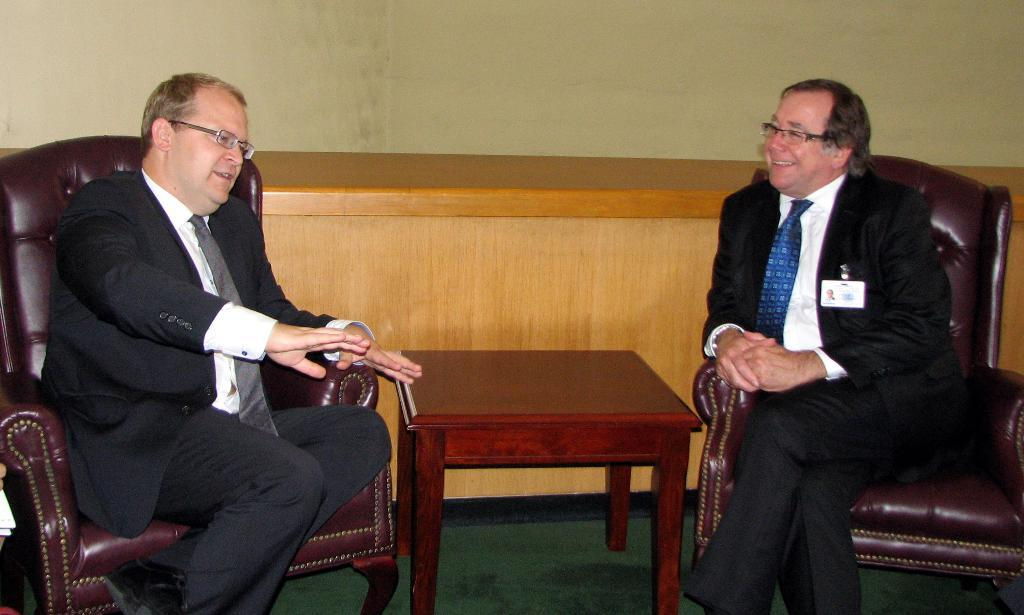How many people are in the image? There are two persons in the image. What are the persons doing in the image? The persons are sitting on chairs. What is present in the image besides the persons? There is a table in the image. What can be seen in the background of the image? There is a wall in the background of the image. What is visible beneath the persons and table? The floor is visible in the image. Can you hear the kitten meowing in the image? There is no kitten present in the image, so it cannot be heard. 